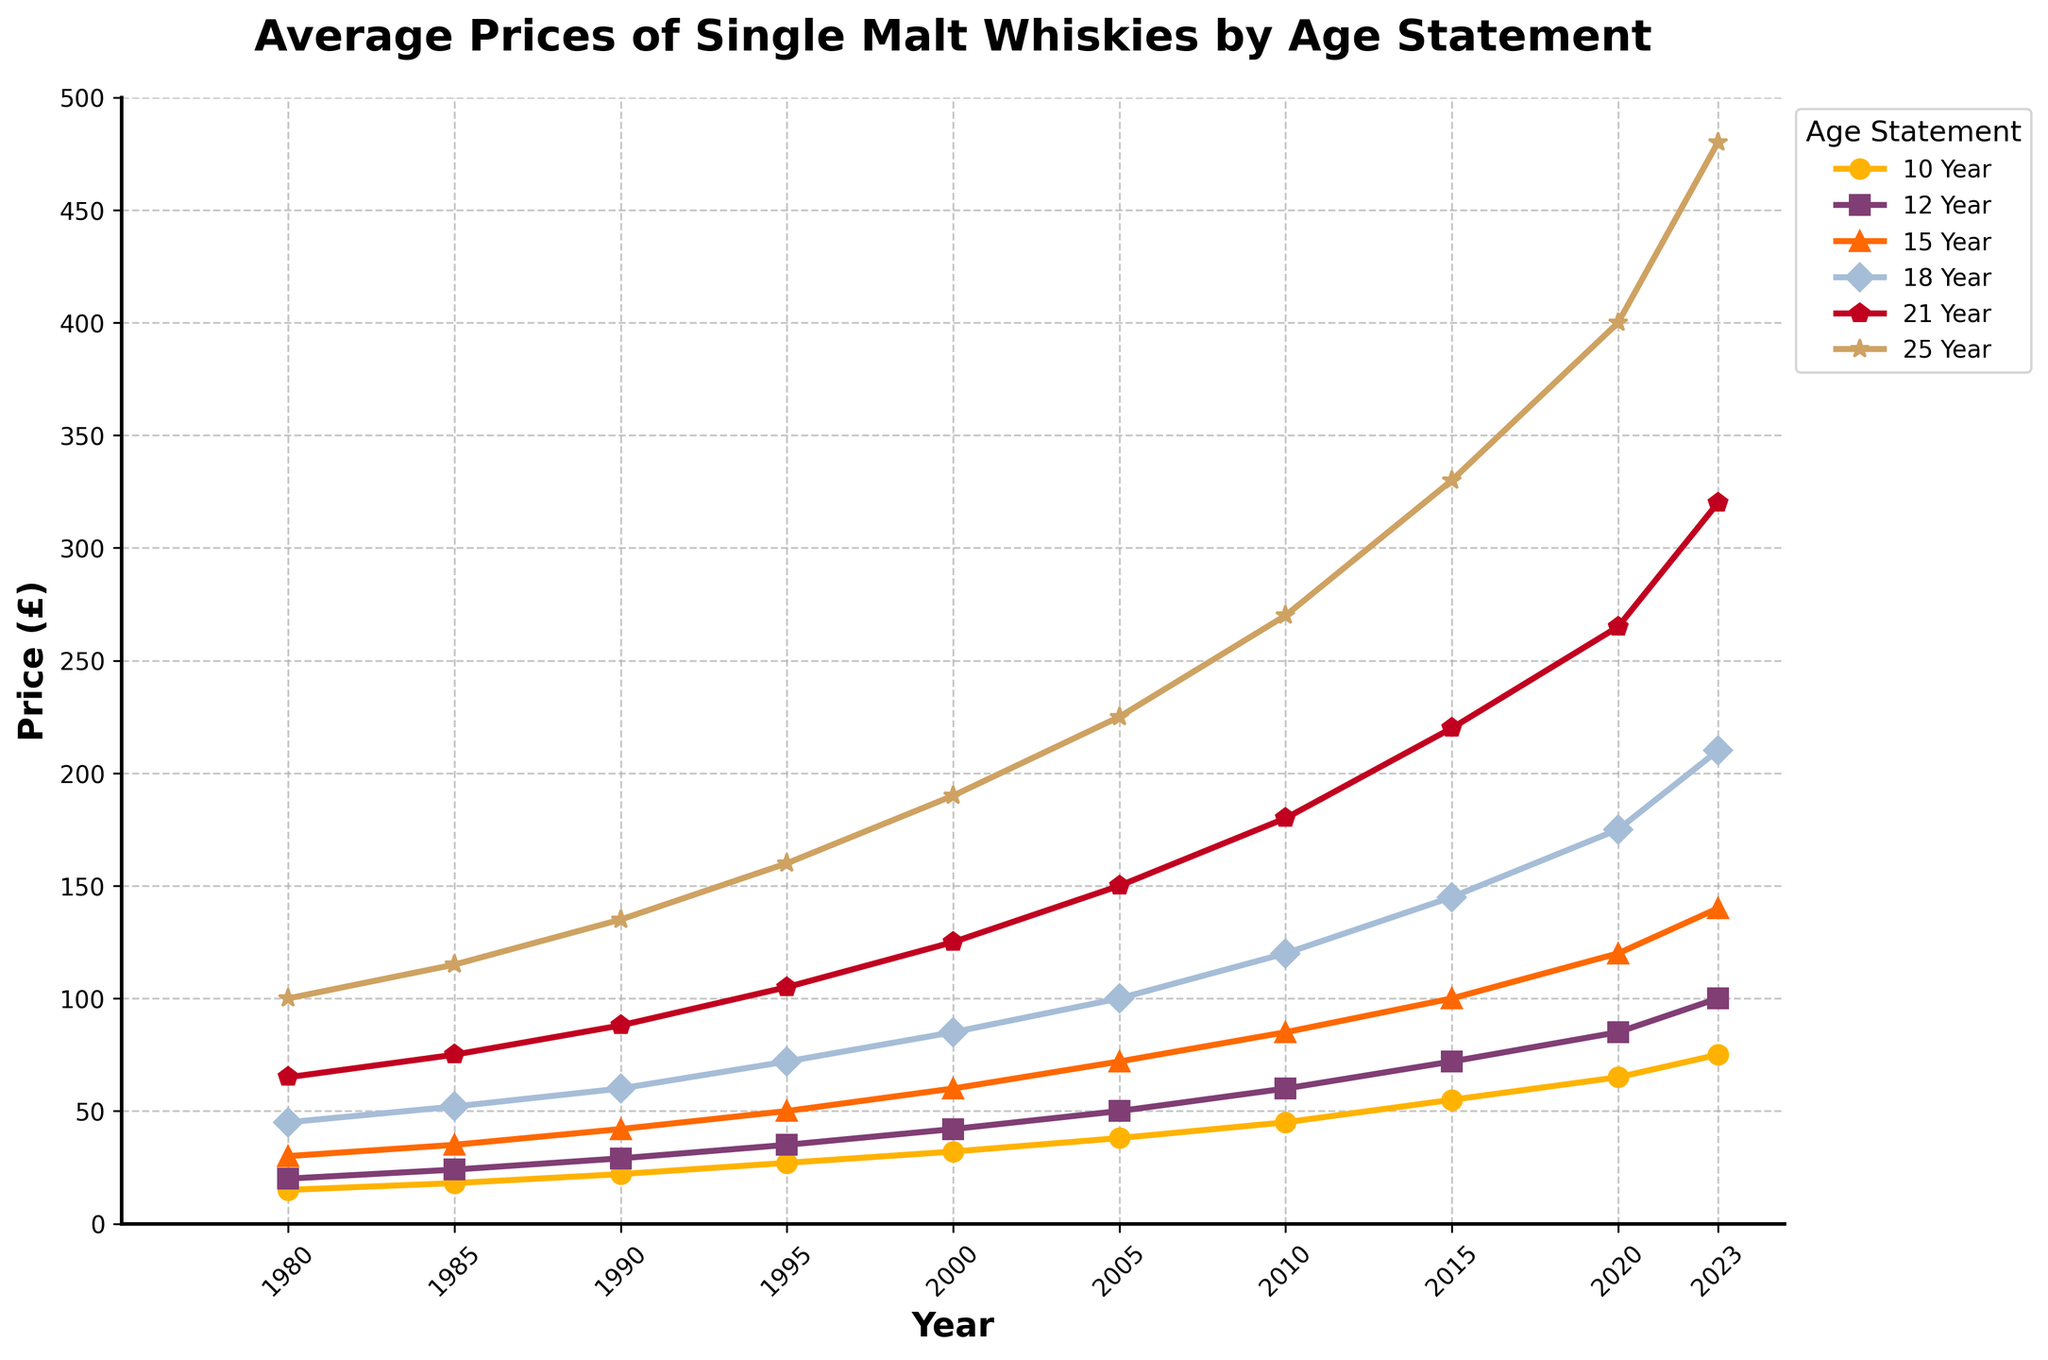Which age statement saw the biggest price increase from 1980 to 2023? To find the answer, calculate the difference in price between 1980 and 2023 for each age statement. The differences are 10 Year: 60, 12 Year: 80, 15 Year: 110, 18 Year: 165, 21 Year: 255, 25 Year: 380. The 25 Year age statement has the biggest increase (380).
Answer: 25 Year Between which years did the 18 Year age statement see the most significant price increase? Look at the 18 Year age statement line. The most noticeable increases occur between 2005 and 2010 (from £100 to £120, increase of £20), and 2020 to 2023 (from £175 to £210, increase of £35). The largest increase is between 2020 and 2023 (£35).
Answer: 2020 to 2023 What is the average price of the 21 Year age statement in 1990 and 2000? Find the prices of the 21 Year statement in 1990 and 2000 (£88 and £125). Compute the average: (88 + 125) / 2 = 106.5.
Answer: 106.5 Which age statement had the smallest price increase from 2005 to 2010? Calculate the price differences for each age statement between 2005 and 2010: 10 Year: 7, 12 Year: 10, 15 Year: 13, 18 Year: 20, 21 Year: 30, 25 Year: 45. The 10 Year age statement had the smallest increase (£7).
Answer: 10 Year Rank the age statements by their average price across all years. Calculate the average price for each age statement across all years and compare them: 10 Year: 39, 12 Year: 51.7, 15 Year: 68.2, 18 Year: 106.7, 21 Year: 159.3, 25 Year: 239.5. The ranking is 10 Year < 12 Year < 15 Year < 18 Year < 21 Year < 25 Year.
Answer: 10 Year < 12 Year < 15 Year < 18 Year < 21 Year < 25 Year How much more expensive was the 25 Year statement compared to the 10 Year statement in 2023? Subtract the price of the 10 Year from the 25 Year in 2023: £480 - £75 = £405.
Answer: £405 Which age statement had the steepest slope between 2015 and 2020? Examine the slopes (price increases) for each age statement between 2015 and 2020: 10 Year: 10, 12 Year: 13, 15 Year: 20, 18 Year: 30, 21 Year: 45, 25 Year: 70. The 25 Year statement has the steepest slope (£70).
Answer: 25 Year Was the price of the 15 Year statement ever higher than 12 Year statement across the years? Compare the prices of 15 Year and 12 Year across all years. The price of 15 Year was always higher than the price of 12 Year.
Answer: Yes 